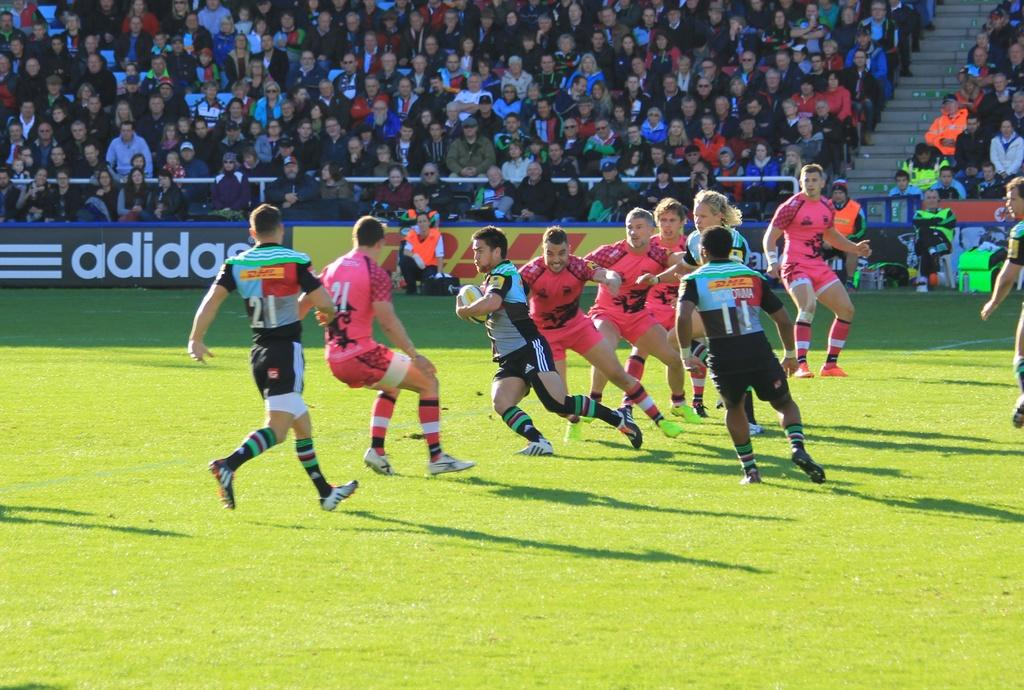<image>
Summarize the visual content of the image. sportsmen on a field in colorful jerseys in front of an Adidas ad 